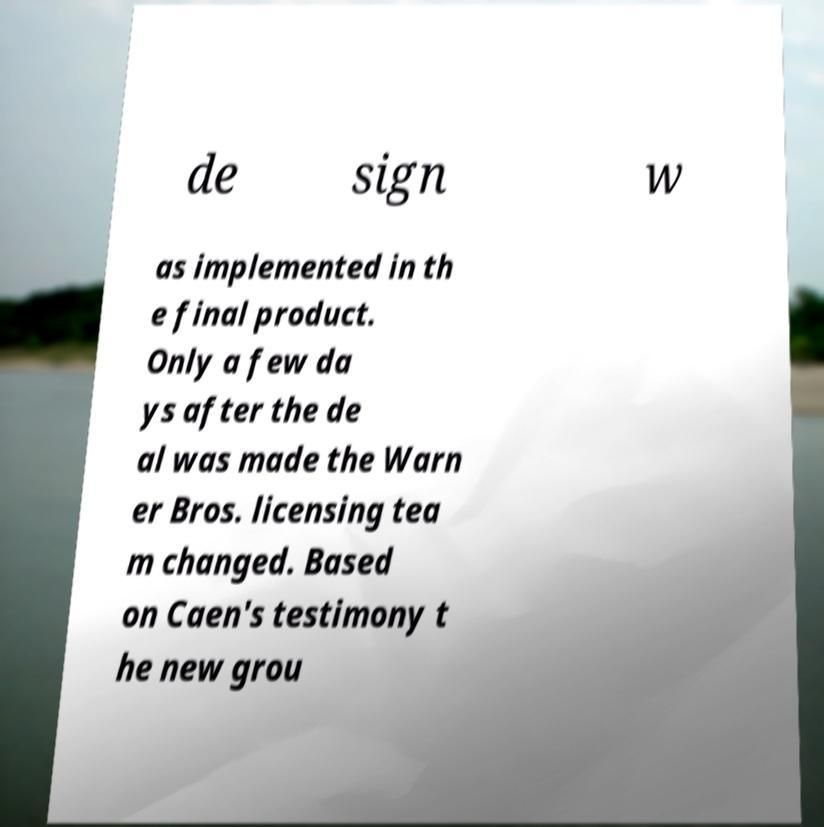Can you accurately transcribe the text from the provided image for me? de sign w as implemented in th e final product. Only a few da ys after the de al was made the Warn er Bros. licensing tea m changed. Based on Caen's testimony t he new grou 